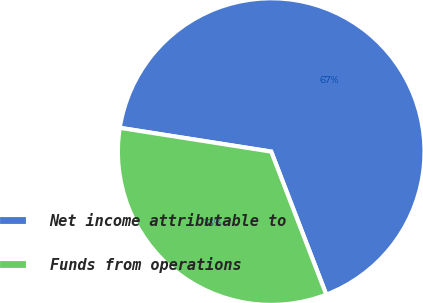Convert chart to OTSL. <chart><loc_0><loc_0><loc_500><loc_500><pie_chart><fcel>Net income attributable to<fcel>Funds from operations<nl><fcel>66.67%<fcel>33.33%<nl></chart> 